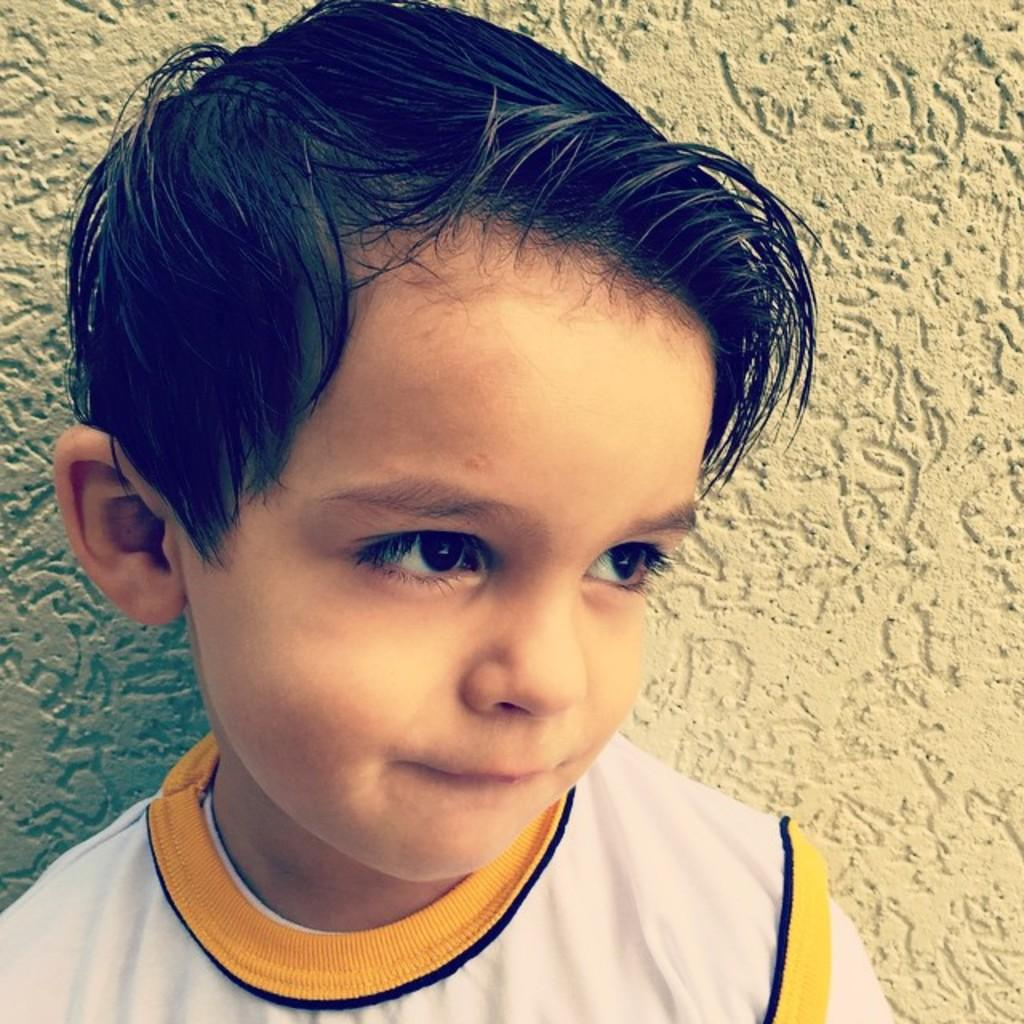Who is the main subject in the image? There is a boy in the image. What can be seen in the background of the image? There is a wall in the background of the image. What type of haircut does the person in the image have? There is no person mentioned in the facts, only a boy. Additionally, the provided facts do not mention any haircut. 